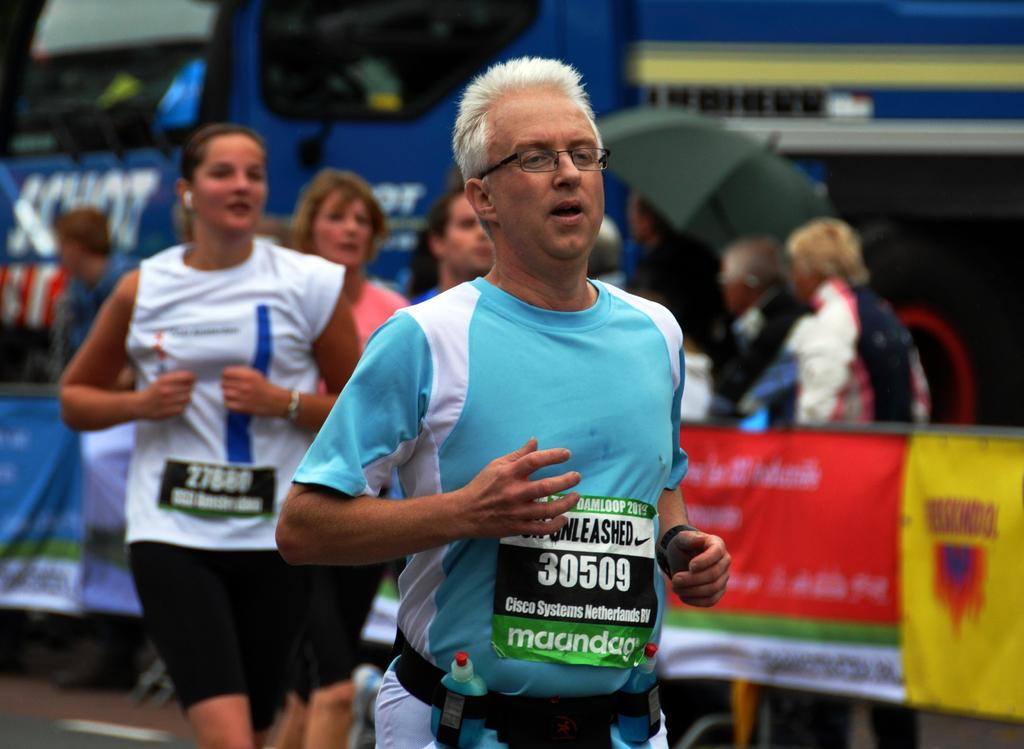Who is the main subject in the image? There is a man in the center of the image. What can be seen in the background of the image? There are people, posters, a vehicle, and an umbrella in the background of the image. Where are the beds located in the image? There are no beds present in the image. What time of day does the image depict, considering the presence of the afternoon? The provided facts do not mention the time of day or the presence of an afternoon, so it cannot be determined from the image. 